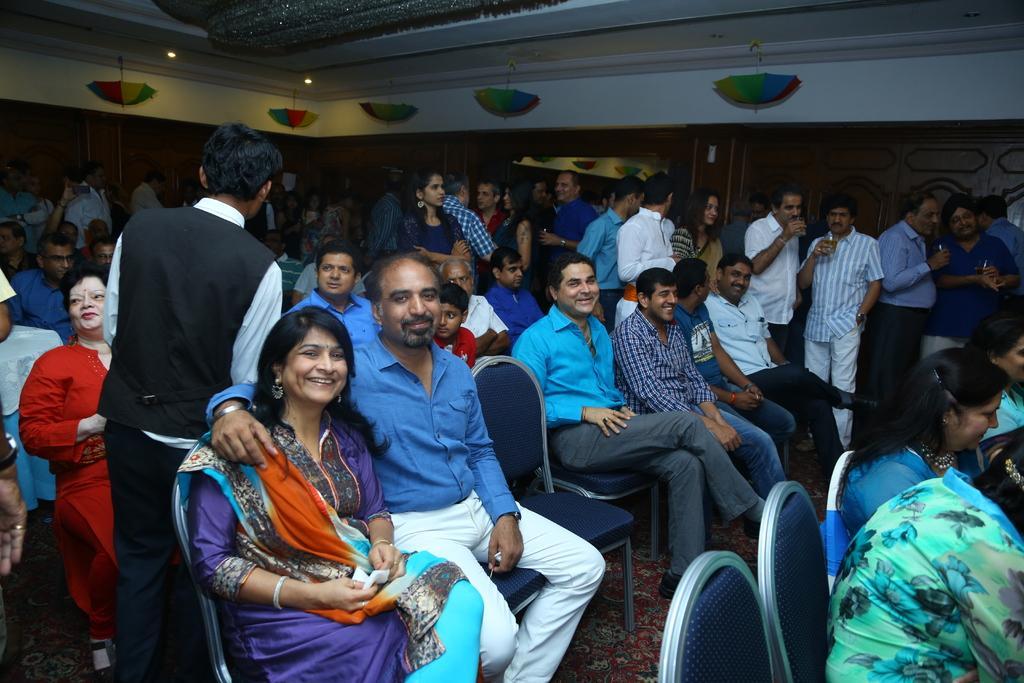Describe this image in one or two sentences. In the center of the image we can see people sitting on the chairs and some of them are standing. We can see glasses in their hands. At the top there are lights and we can see decors. 